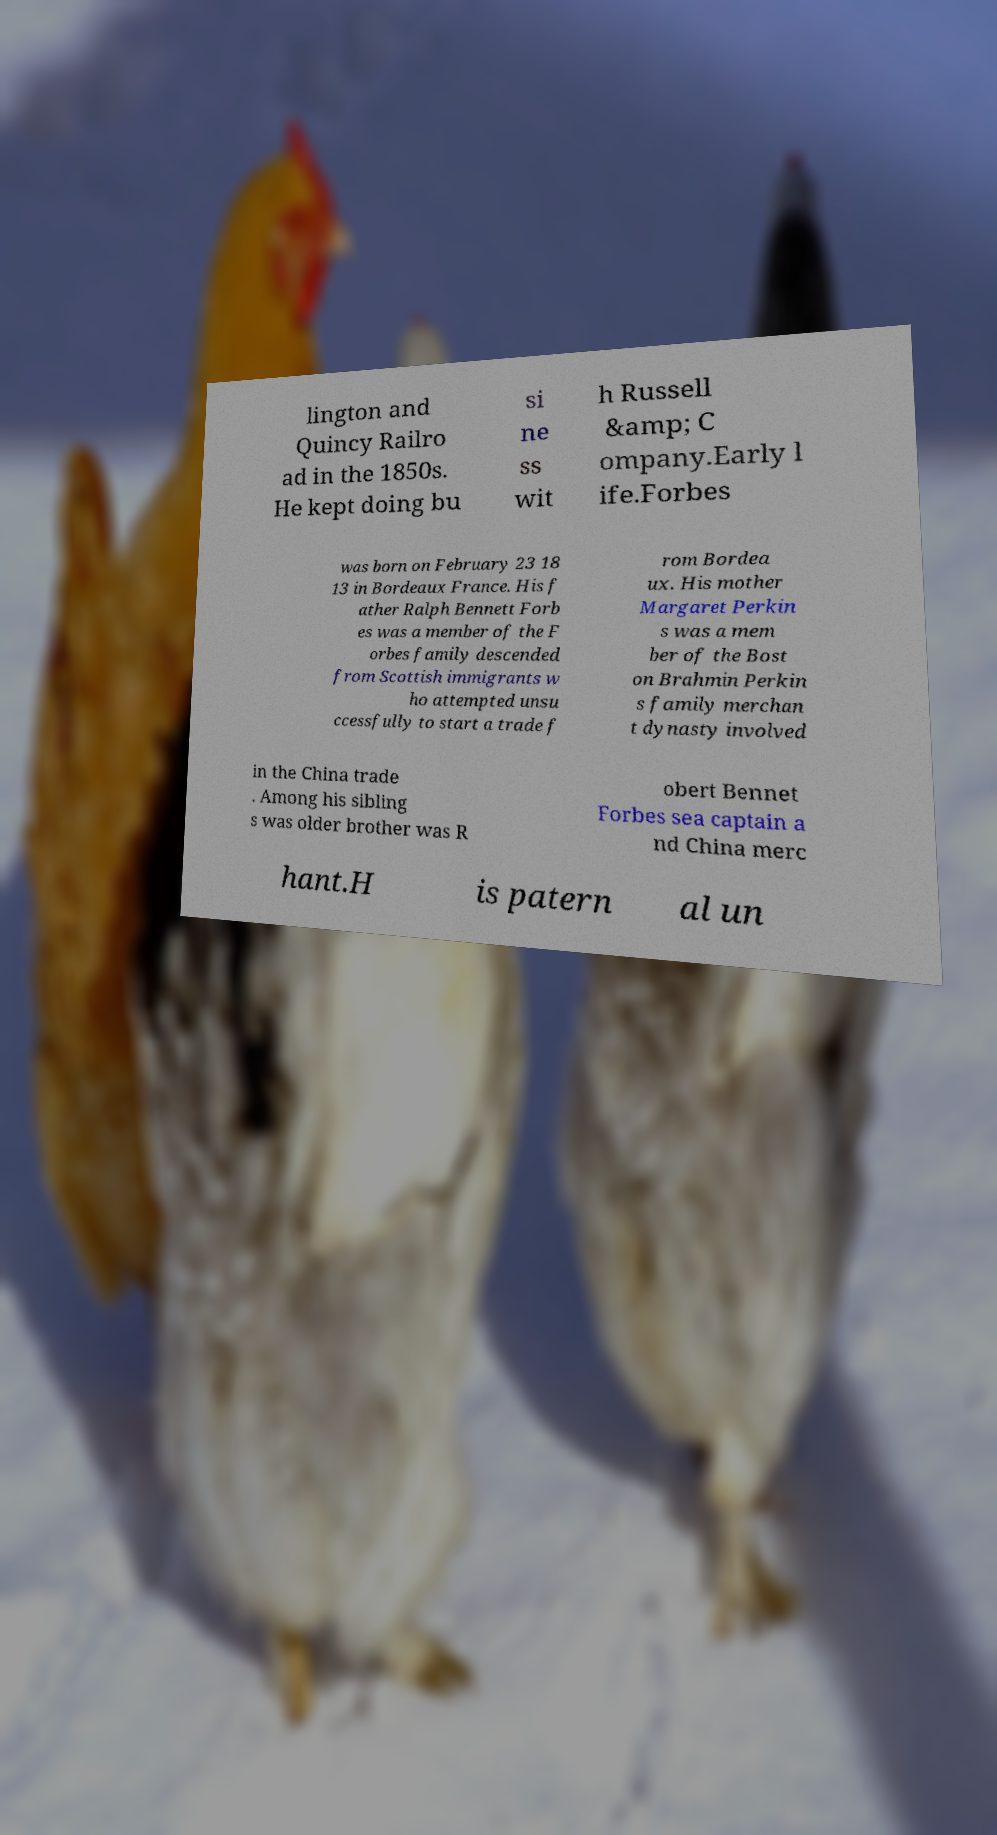I need the written content from this picture converted into text. Can you do that? lington and Quincy Railro ad in the 1850s. He kept doing bu si ne ss wit h Russell &amp; C ompany.Early l ife.Forbes was born on February 23 18 13 in Bordeaux France. His f ather Ralph Bennett Forb es was a member of the F orbes family descended from Scottish immigrants w ho attempted unsu ccessfully to start a trade f rom Bordea ux. His mother Margaret Perkin s was a mem ber of the Bost on Brahmin Perkin s family merchan t dynasty involved in the China trade . Among his sibling s was older brother was R obert Bennet Forbes sea captain a nd China merc hant.H is patern al un 